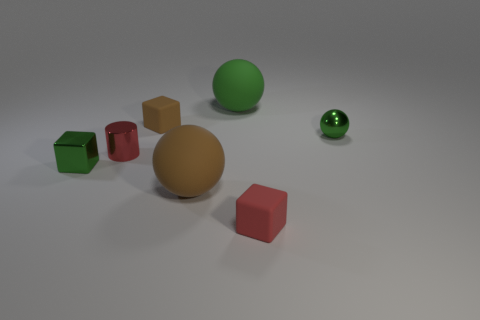There is a green matte object that is the same size as the brown ball; what is its shape?
Your answer should be very brief. Sphere. What number of other objects are there of the same color as the shiny cube?
Your answer should be compact. 2. How big is the block behind the ball that is to the right of the big green matte sphere?
Your answer should be compact. Small. Does the green object in front of the small green ball have the same material as the red cylinder?
Give a very brief answer. Yes. The green metal object right of the red metal object has what shape?
Ensure brevity in your answer.  Sphere. How many red metal cylinders are the same size as the metal block?
Keep it short and to the point. 1. What size is the green matte object?
Provide a short and direct response. Large. There is a green shiny ball; what number of brown objects are in front of it?
Offer a terse response. 1. The large green object that is made of the same material as the tiny red cube is what shape?
Give a very brief answer. Sphere. Are there fewer metal things in front of the cylinder than big brown matte things that are behind the small red block?
Make the answer very short. No. 